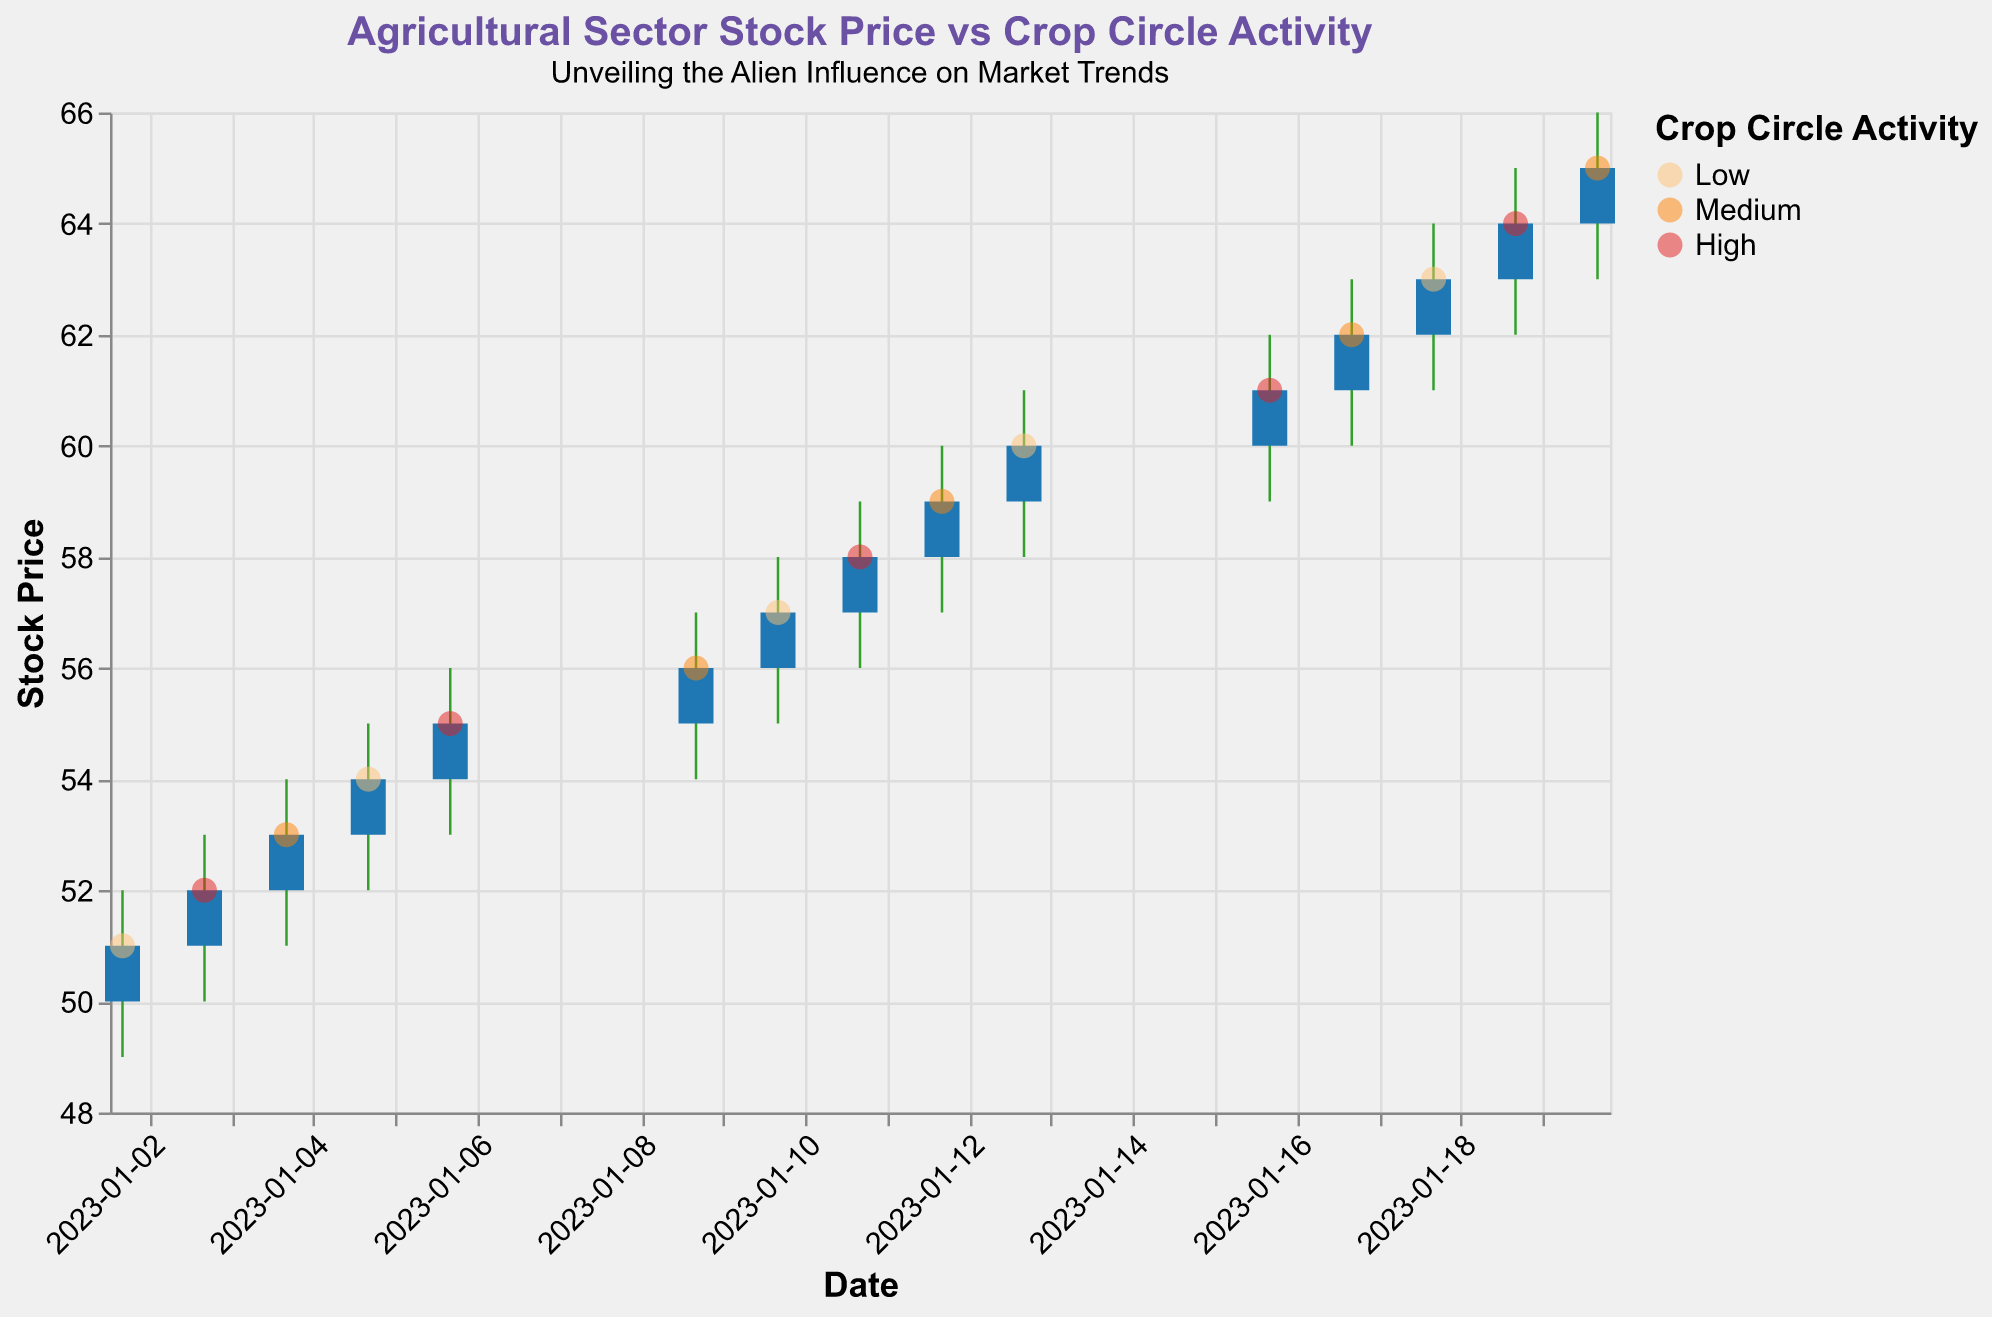What is the title of the plot? The title is usually found at the top of the plot in a larger or bold font. It provides a general description of what the plot represents.
Answer: Agricultural Sector Stock Price vs Crop Circle Activity What is the subtitle of the plot? Subtitles are often found just below the main title and provide additional context or a brief description of the plot's theme.
Answer: Unveiling the Alien Influence on Market Trends What are the colors representing high crop circle activity levels in the plot? By referring to the legend, we can see which colors correspond to each level of crop circle activity. The legend helps in decoding the color codes used in the plot.
Answer: Red On which date did the stock price have the highest volume? We need to check the volume for each date and identify the date with the maximum volume. The highest bar in the plot corresponds to the highest volume.
Answer: January 20, 2023 How did the stock price change on January 6, 2023? By examining the candlestick for January 6, we see the open, high, low, and close prices. We compare the open and close prices to understand the price movement.
Answer: It increased What is the relationship between stock price and high crop circle activity? We need to identify data points with high crop circle activity and examine the corresponding stock prices to interpret any patterns or trends.
Answer: Usually, the stock price increases Which day had the largest single-day price range (high-low)? For each date, calculate the difference between the high and low prices. Compare these differences to determine the largest range.
Answer: January 19, 2023 How many days experienced medium crop circle activity, and what was the overall stock price trend on those days? Count the days with medium activity from the legend and observe the stock price movements on those days to derive the trend.
Answer: 5 days, upward trend Compare the stock price on January 2, 2023, and January 20, 2023. Find the opening and closing prices on January 2 and January 20. Compare the closing prices to see the change over the period.
Answer: Increased from 51 to 65 What was the closing stock price for days with low crop circle activity? Identify the dates with low activity from the legend and list their closing prices from the candlesticks. These values are visually accessible.
Answer: 51, 54, 57, 60, 63 